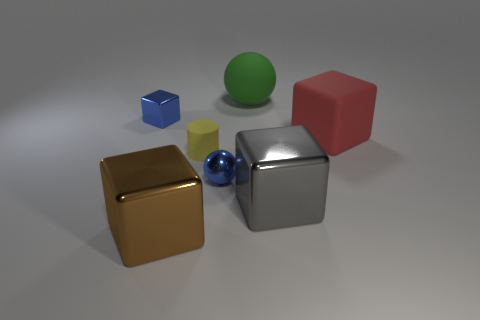Are there any things of the same color as the small shiny block?
Offer a terse response. Yes. Does the small object that is behind the tiny rubber thing have the same color as the tiny metallic thing to the right of the large brown metallic block?
Offer a terse response. Yes. What is the shape of the yellow matte thing?
Offer a terse response. Cylinder. There is a large sphere; what number of big matte objects are on the left side of it?
Keep it short and to the point. 0. How many tiny blue spheres have the same material as the large gray cube?
Provide a succinct answer. 1. Does the object that is in front of the gray metallic block have the same material as the tiny blue ball?
Offer a terse response. Yes. Is there a cylinder?
Make the answer very short. Yes. There is a matte object that is to the left of the big red block and in front of the blue shiny cube; how big is it?
Provide a succinct answer. Small. Is the number of big brown metallic blocks to the right of the large red rubber object greater than the number of blocks behind the big brown object?
Give a very brief answer. No. What is the size of the block that is the same color as the metal sphere?
Your answer should be very brief. Small. 